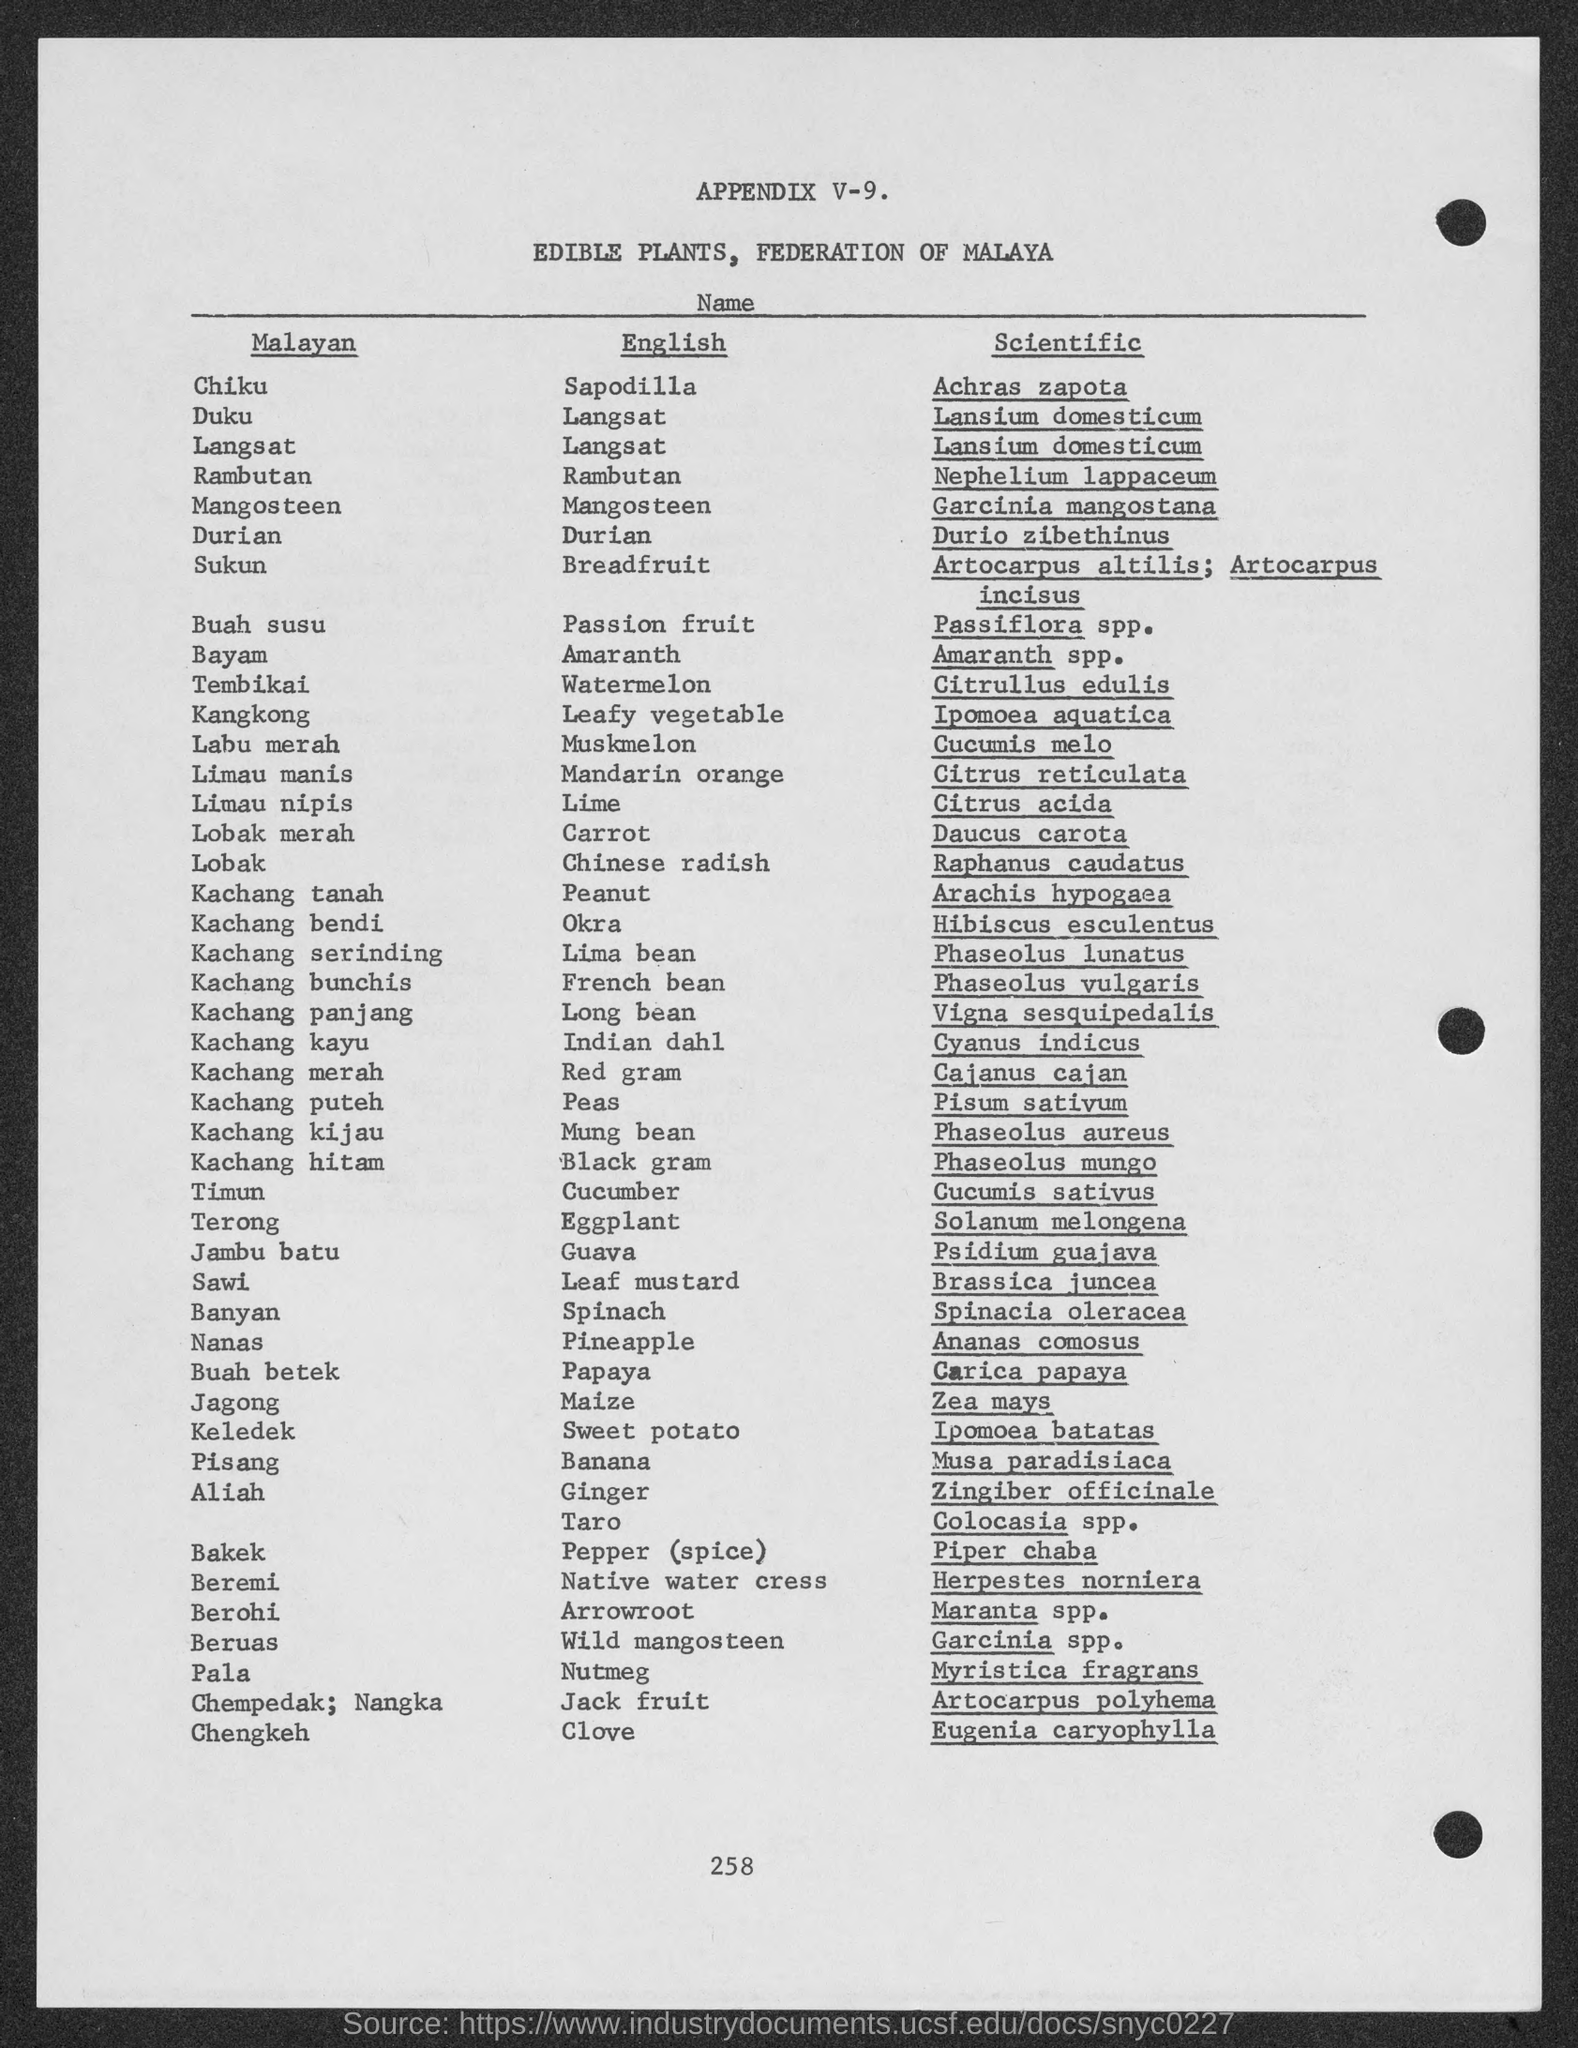Mention a couple of crucial points in this snapshot. The Malayan name "Buah susu" translates to "Passion fruit" in English. The Malayan name "Tembikai" is equivalent to the English word "Watermelon" in meaning. The English name for the Malayan name "Lobak merah" is "carrot. The Malayan name "Bayam" has an English equivalent, which is "Amaranth." The Malayan name "Chiku" is also known as Sapodilla in English. 